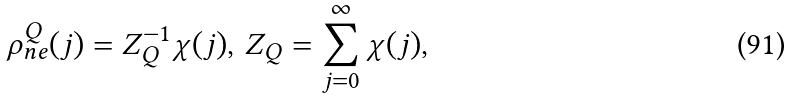Convert formula to latex. <formula><loc_0><loc_0><loc_500><loc_500>\rho _ { n e } ^ { Q } ( j ) = Z _ { Q } ^ { - 1 } \chi ( j ) , \, Z _ { Q } = \sum _ { j = 0 } ^ { \infty } \chi ( j ) ,</formula> 